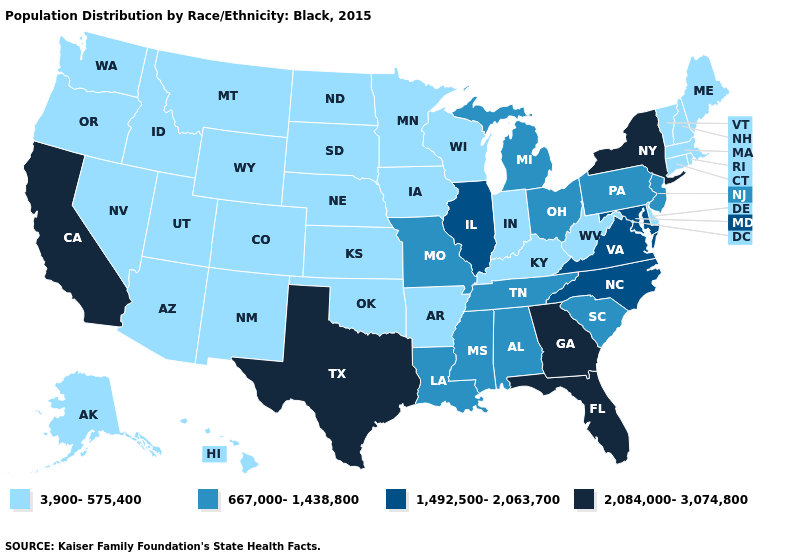What is the lowest value in states that border Washington?
Keep it brief. 3,900-575,400. Which states have the lowest value in the South?
Answer briefly. Arkansas, Delaware, Kentucky, Oklahoma, West Virginia. Among the states that border California , which have the highest value?
Keep it brief. Arizona, Nevada, Oregon. Name the states that have a value in the range 2,084,000-3,074,800?
Concise answer only. California, Florida, Georgia, New York, Texas. Name the states that have a value in the range 1,492,500-2,063,700?
Short answer required. Illinois, Maryland, North Carolina, Virginia. Name the states that have a value in the range 2,084,000-3,074,800?
Keep it brief. California, Florida, Georgia, New York, Texas. Which states have the highest value in the USA?
Short answer required. California, Florida, Georgia, New York, Texas. Among the states that border Minnesota , which have the highest value?
Give a very brief answer. Iowa, North Dakota, South Dakota, Wisconsin. Name the states that have a value in the range 1,492,500-2,063,700?
Quick response, please. Illinois, Maryland, North Carolina, Virginia. Name the states that have a value in the range 667,000-1,438,800?
Answer briefly. Alabama, Louisiana, Michigan, Mississippi, Missouri, New Jersey, Ohio, Pennsylvania, South Carolina, Tennessee. What is the value of Oklahoma?
Short answer required. 3,900-575,400. How many symbols are there in the legend?
Give a very brief answer. 4. Among the states that border Michigan , which have the highest value?
Short answer required. Ohio. Which states have the lowest value in the USA?
Answer briefly. Alaska, Arizona, Arkansas, Colorado, Connecticut, Delaware, Hawaii, Idaho, Indiana, Iowa, Kansas, Kentucky, Maine, Massachusetts, Minnesota, Montana, Nebraska, Nevada, New Hampshire, New Mexico, North Dakota, Oklahoma, Oregon, Rhode Island, South Dakota, Utah, Vermont, Washington, West Virginia, Wisconsin, Wyoming. 